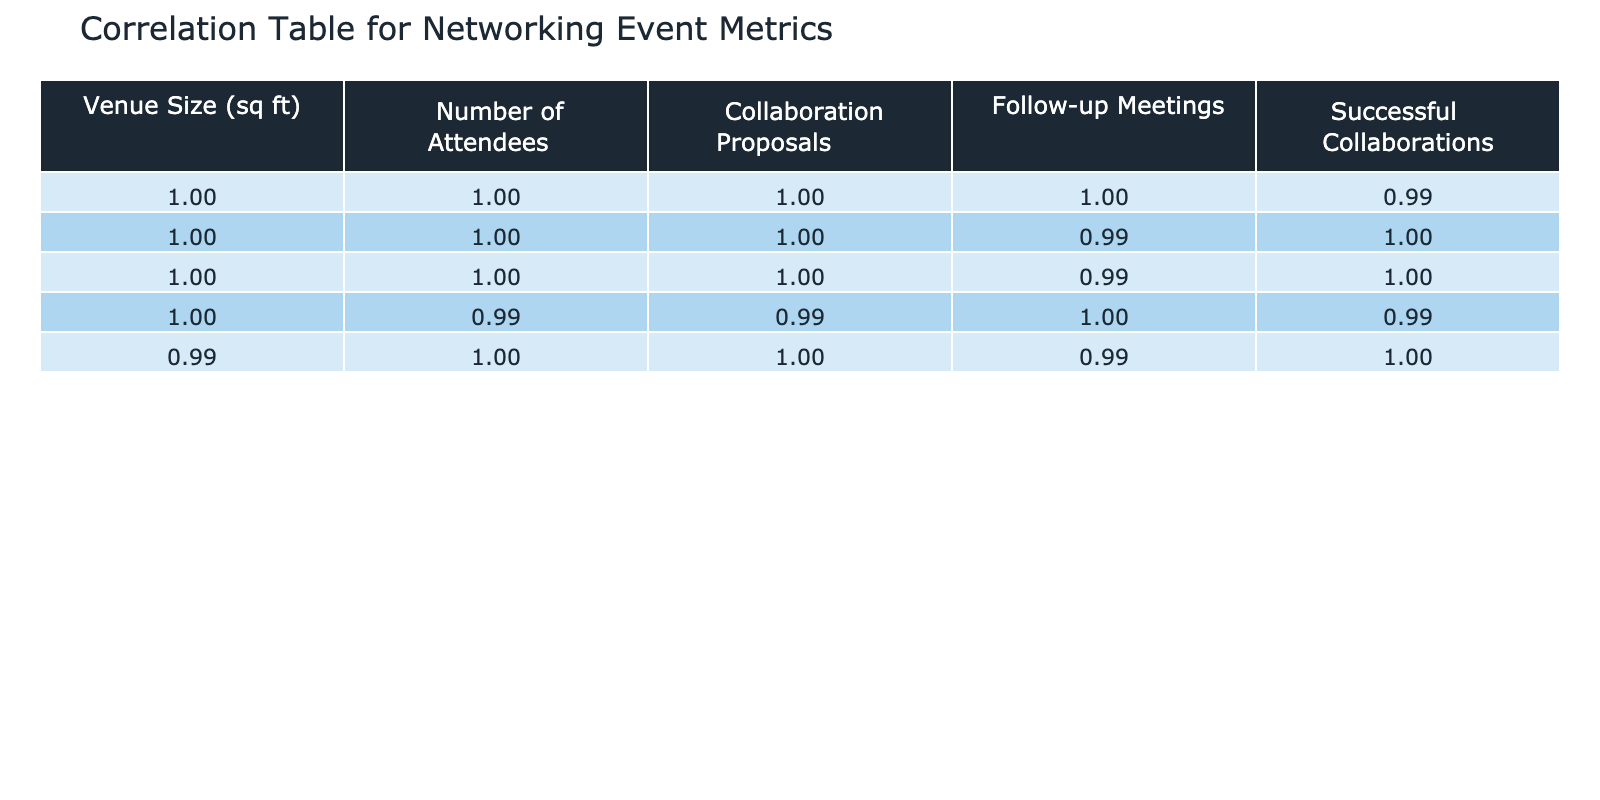What is the correlation between venue size and the number of attendees? Looking at the correlation table, the correlation coefficient between venue size and the number of attendees is 0.99. This indicates a very strong positive relationship, meaning as venue size increases, the number of attendees also increases.
Answer: 0.99 What is the correlation coefficient for successful collaborations and collaboration proposals? The correlation coefficient for successful collaborations and collaboration proposals is 0.96 according to the table. This indicates that there is a strong positive relationship between these two metrics, suggesting that more collaboration proposals lead to more successful collaborations.
Answer: 0.96 What is the average number of follow-up meetings across all venue sizes? To find the average, add the number of follow-up meetings (3 + 7 + 10 + 15 + 20 + 25 + 30 + 35 = 145) and divide by the total number of venue sizes (8). This gives an average of 145/8 = 18.125.
Answer: 18.125 Is there a strong correlation between the number of attendees and successful collaborations? Yes, the correlation coefficient between the number of attendees and successful collaborations is 0.95, indicating a strong positive relationship. This suggests that more attendees are associated with a higher number of successful collaborations.
Answer: Yes Which venue size corresponds to the highest number of collaboration proposals? The table shows that the highest number of collaboration proposals, 50, corresponds to a venue size of 10,000 square feet. Therefore, the largest venue size allows for the most collaboration proposals.
Answer: 10,000 sq ft 